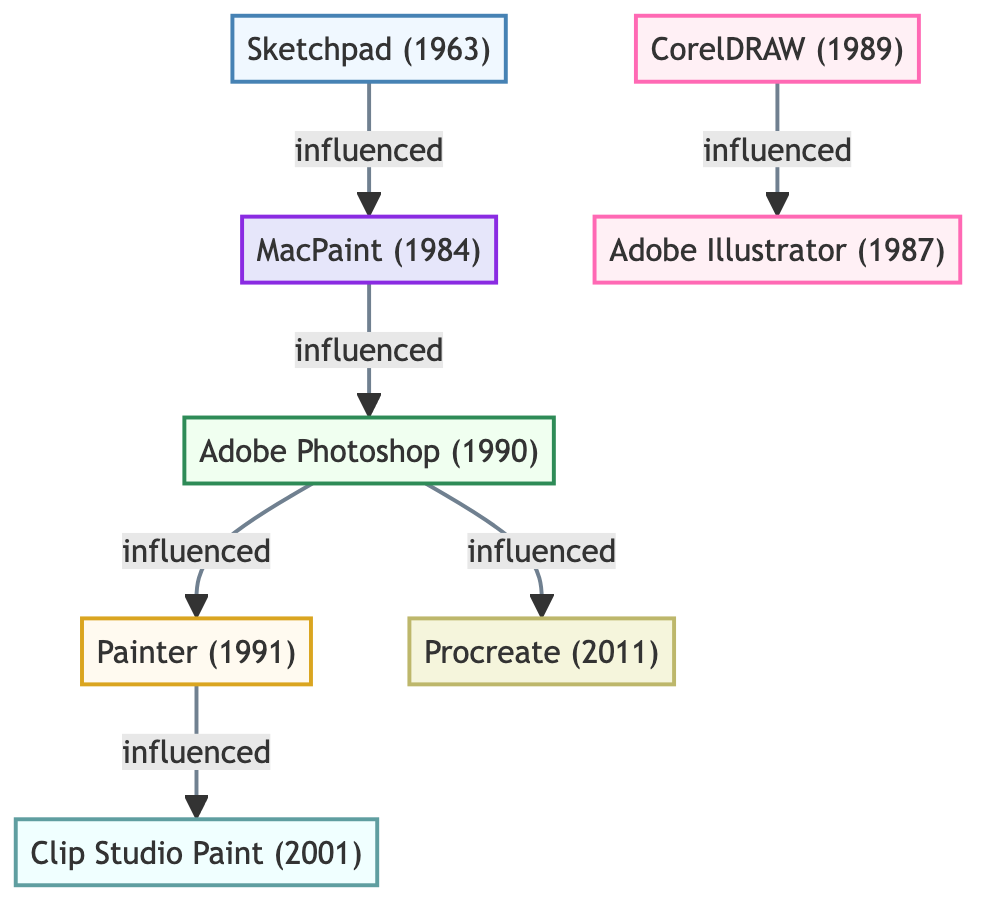What is the year of Adobe Photoshop? Adobe Photoshop is listed as being created in the year 1990, which can be found in the node description of Adobe Photoshop within the diagram.
Answer: 1990 Which tool influenced Procreate? Tracing through the diagram, Procreate is influenced by Adobe Photoshop, as indicated by the connection line linking Adobe Photoshop to Procreate.
Answer: Adobe Photoshop How many tools are categorized as Vector Graphics? From the diagram, we identify two nodes labeled as Vector Graphics: CorelDRAW and Adobe Illustrator. By counting these nodes, we determine there are 2.
Answer: 2 What is the relationship between MacPaint and Adobe Photoshop? The diagram shows an "influenced" link from MacPaint to Adobe Photoshop, indicating that MacPaint had an impact on the development of Adobe Photoshop.
Answer: influenced Which software was developed first, CorelDRAW or Adobe Illustrator? Looking at the years presented in the nodes, CorelDRAW was created in 1989, while Adobe Illustrator was developed in 1987. Hence, Adobe Illustrator came first.
Answer: Adobe Illustrator How many connections are there in total between the tools? By reviewing the links between the nodes in the diagram, we count a total of six connections that illustrate how different tools influenced one another.
Answer: 6 What type of graphics is Painter associated with? The description for Painter indicates it is categorized as Simulated Traditional Media, clearly stating its focus on replicating traditional art styles in a digital format.
Answer: Simulated Traditional Media Which software was influenced by both Adobe Photoshop and Painter? Following the diagram, Clip Studio Paint is influenced by Painter, and it is also connected to Adobe Photoshop through the paths shown in the diagram.
Answer: Clip Studio Paint 